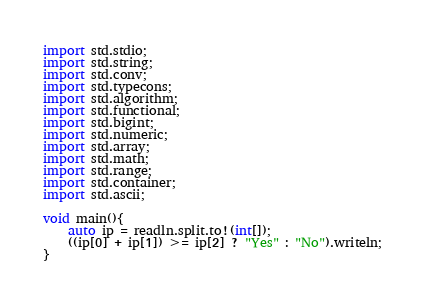Convert code to text. <code><loc_0><loc_0><loc_500><loc_500><_D_>import std.stdio;
import std.string;
import std.conv;
import std.typecons;
import std.algorithm;
import std.functional;
import std.bigint;
import std.numeric;
import std.array;
import std.math;
import std.range;
import std.container;
import std.ascii;

void main(){
	auto ip = readln.split.to!(int[]);
	((ip[0] + ip[1]) >= ip[2] ? "Yes" : "No").writeln;
}</code> 